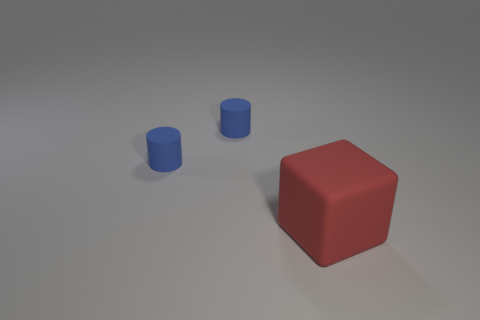How many objects are there, and do they differ in size? There are a total of three objects in the image. There is one large red cube, and two smaller blue cylinders. The cylinders are significantly smaller in height and diameter when compared to the dimensions of the cube. 